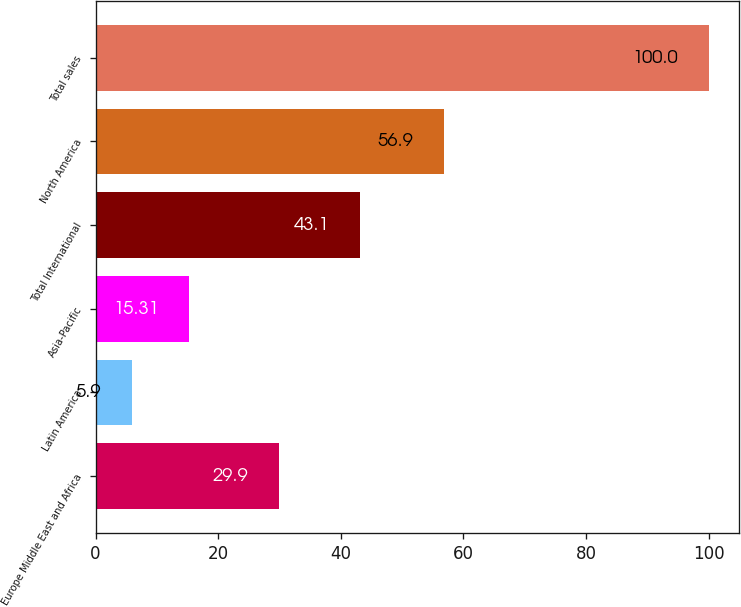<chart> <loc_0><loc_0><loc_500><loc_500><bar_chart><fcel>Europe Middle East and Africa<fcel>Latin America<fcel>Asia-Pacific<fcel>Total International<fcel>North America<fcel>Total sales<nl><fcel>29.9<fcel>5.9<fcel>15.31<fcel>43.1<fcel>56.9<fcel>100<nl></chart> 